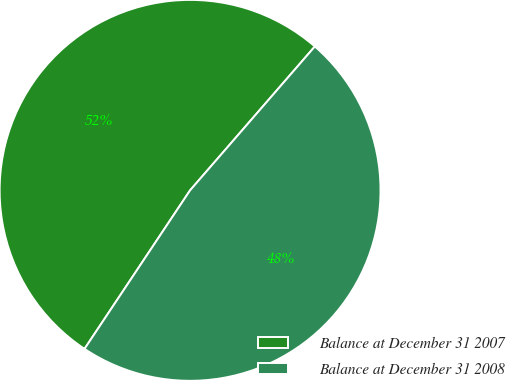<chart> <loc_0><loc_0><loc_500><loc_500><pie_chart><fcel>Balance at December 31 2007<fcel>Balance at December 31 2008<nl><fcel>52.02%<fcel>47.98%<nl></chart> 